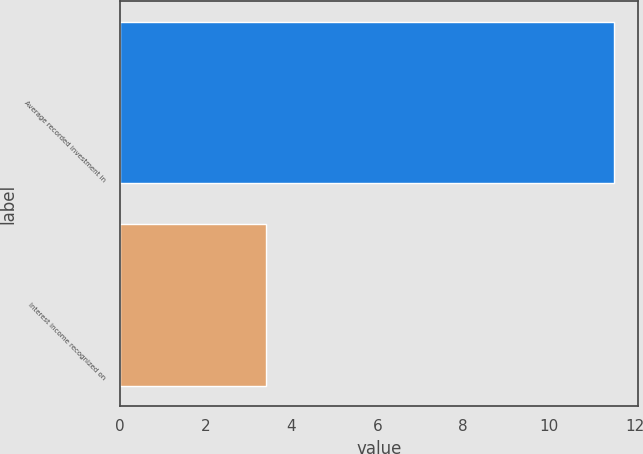Convert chart. <chart><loc_0><loc_0><loc_500><loc_500><bar_chart><fcel>Average recorded investment in<fcel>Interest income recognized on<nl><fcel>11.5<fcel>3.4<nl></chart> 